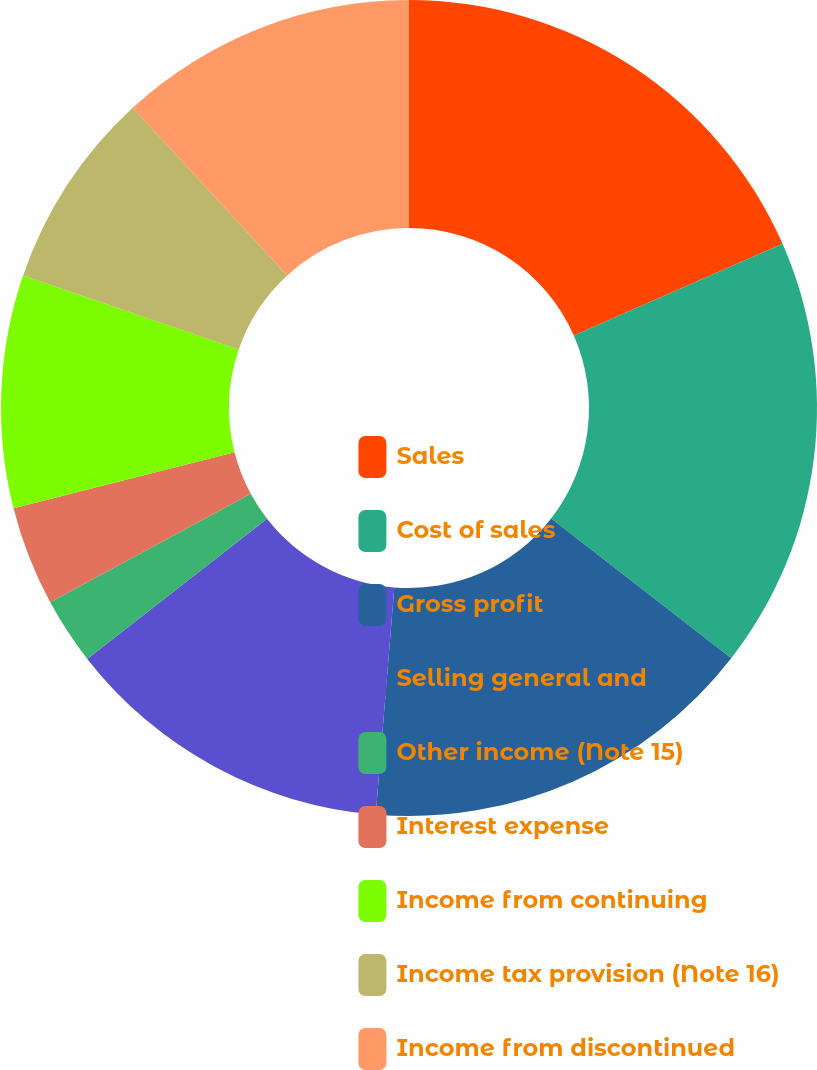Convert chart. <chart><loc_0><loc_0><loc_500><loc_500><pie_chart><fcel>Sales<fcel>Cost of sales<fcel>Gross profit<fcel>Selling general and<fcel>Other income (Note 15)<fcel>Interest expense<fcel>Income from continuing<fcel>Income tax provision (Note 16)<fcel>Income from discontinued<nl><fcel>18.41%<fcel>17.1%<fcel>15.79%<fcel>13.16%<fcel>2.64%<fcel>3.95%<fcel>9.21%<fcel>7.9%<fcel>11.84%<nl></chart> 